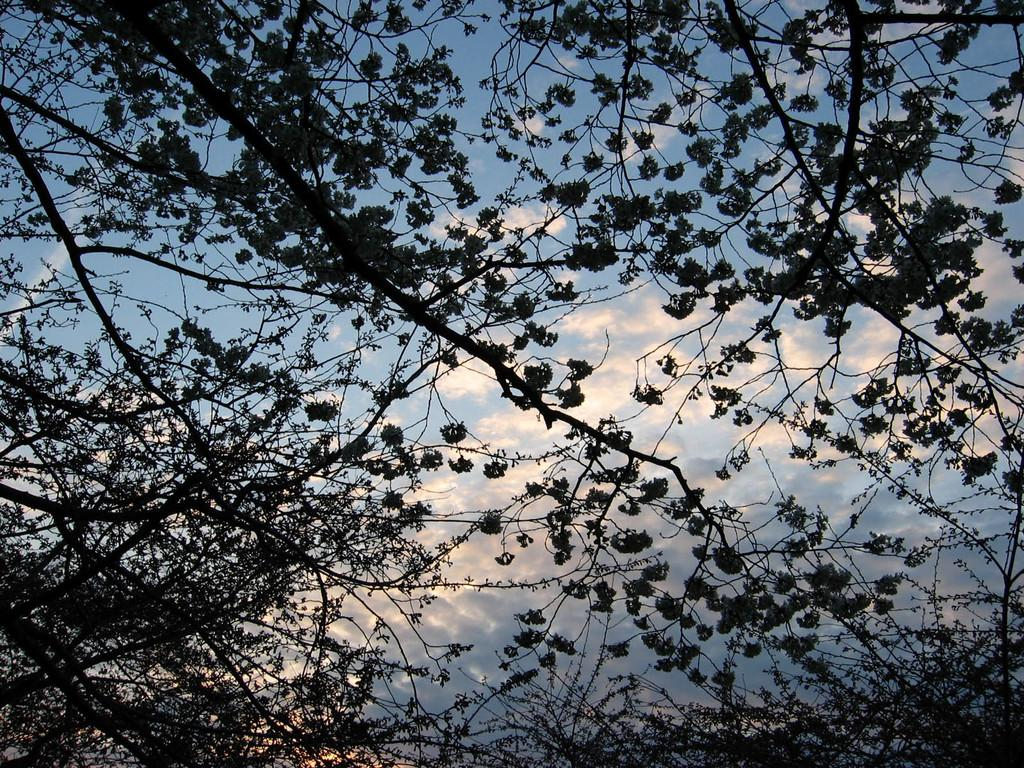What type of vegetation is present in the image? There are trees with branches and leaves in the image. What can be seen in the background of the image? There are clouds in the background of the image. What color is the sky in the image? The sky is blue in the image. What type of stomach is visible in the image? There is no stomach present in the image; it features trees, clouds, and a blue sky. What kind of board can be seen being used by the trees in the image? There is no board present in the image; it features trees, clouds, and a blue sky. 